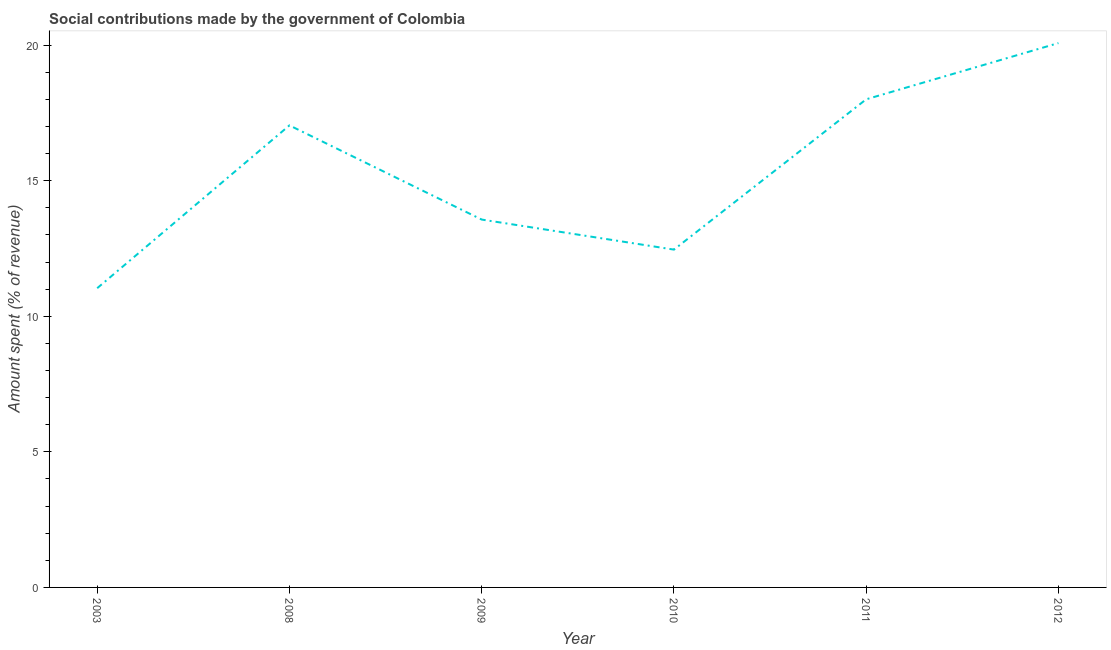What is the amount spent in making social contributions in 2009?
Offer a very short reply. 13.57. Across all years, what is the maximum amount spent in making social contributions?
Provide a succinct answer. 20.08. Across all years, what is the minimum amount spent in making social contributions?
Offer a terse response. 11.04. In which year was the amount spent in making social contributions maximum?
Your answer should be compact. 2012. What is the sum of the amount spent in making social contributions?
Ensure brevity in your answer.  92.18. What is the difference between the amount spent in making social contributions in 2008 and 2011?
Your response must be concise. -0.96. What is the average amount spent in making social contributions per year?
Offer a very short reply. 15.36. What is the median amount spent in making social contributions?
Offer a very short reply. 15.3. In how many years, is the amount spent in making social contributions greater than 12 %?
Offer a terse response. 5. What is the ratio of the amount spent in making social contributions in 2009 to that in 2011?
Provide a short and direct response. 0.75. What is the difference between the highest and the second highest amount spent in making social contributions?
Keep it short and to the point. 2.07. What is the difference between the highest and the lowest amount spent in making social contributions?
Your response must be concise. 9.04. How many years are there in the graph?
Your answer should be compact. 6. What is the difference between two consecutive major ticks on the Y-axis?
Make the answer very short. 5. Does the graph contain grids?
Offer a very short reply. No. What is the title of the graph?
Your response must be concise. Social contributions made by the government of Colombia. What is the label or title of the X-axis?
Offer a terse response. Year. What is the label or title of the Y-axis?
Ensure brevity in your answer.  Amount spent (% of revenue). What is the Amount spent (% of revenue) in 2003?
Keep it short and to the point. 11.04. What is the Amount spent (% of revenue) of 2008?
Offer a very short reply. 17.04. What is the Amount spent (% of revenue) of 2009?
Offer a very short reply. 13.57. What is the Amount spent (% of revenue) of 2010?
Ensure brevity in your answer.  12.46. What is the Amount spent (% of revenue) in 2011?
Give a very brief answer. 18. What is the Amount spent (% of revenue) of 2012?
Your answer should be compact. 20.08. What is the difference between the Amount spent (% of revenue) in 2003 and 2008?
Your response must be concise. -6. What is the difference between the Amount spent (% of revenue) in 2003 and 2009?
Offer a very short reply. -2.53. What is the difference between the Amount spent (% of revenue) in 2003 and 2010?
Ensure brevity in your answer.  -1.42. What is the difference between the Amount spent (% of revenue) in 2003 and 2011?
Your answer should be compact. -6.97. What is the difference between the Amount spent (% of revenue) in 2003 and 2012?
Your answer should be compact. -9.04. What is the difference between the Amount spent (% of revenue) in 2008 and 2009?
Offer a very short reply. 3.47. What is the difference between the Amount spent (% of revenue) in 2008 and 2010?
Make the answer very short. 4.58. What is the difference between the Amount spent (% of revenue) in 2008 and 2011?
Your answer should be compact. -0.96. What is the difference between the Amount spent (% of revenue) in 2008 and 2012?
Offer a terse response. -3.04. What is the difference between the Amount spent (% of revenue) in 2009 and 2010?
Your answer should be very brief. 1.11. What is the difference between the Amount spent (% of revenue) in 2009 and 2011?
Keep it short and to the point. -4.44. What is the difference between the Amount spent (% of revenue) in 2009 and 2012?
Provide a short and direct response. -6.51. What is the difference between the Amount spent (% of revenue) in 2010 and 2011?
Your answer should be very brief. -5.54. What is the difference between the Amount spent (% of revenue) in 2010 and 2012?
Provide a succinct answer. -7.62. What is the difference between the Amount spent (% of revenue) in 2011 and 2012?
Give a very brief answer. -2.07. What is the ratio of the Amount spent (% of revenue) in 2003 to that in 2008?
Give a very brief answer. 0.65. What is the ratio of the Amount spent (% of revenue) in 2003 to that in 2009?
Your answer should be very brief. 0.81. What is the ratio of the Amount spent (% of revenue) in 2003 to that in 2010?
Provide a short and direct response. 0.89. What is the ratio of the Amount spent (% of revenue) in 2003 to that in 2011?
Offer a very short reply. 0.61. What is the ratio of the Amount spent (% of revenue) in 2003 to that in 2012?
Ensure brevity in your answer.  0.55. What is the ratio of the Amount spent (% of revenue) in 2008 to that in 2009?
Provide a succinct answer. 1.26. What is the ratio of the Amount spent (% of revenue) in 2008 to that in 2010?
Make the answer very short. 1.37. What is the ratio of the Amount spent (% of revenue) in 2008 to that in 2011?
Provide a short and direct response. 0.95. What is the ratio of the Amount spent (% of revenue) in 2008 to that in 2012?
Offer a terse response. 0.85. What is the ratio of the Amount spent (% of revenue) in 2009 to that in 2010?
Your answer should be very brief. 1.09. What is the ratio of the Amount spent (% of revenue) in 2009 to that in 2011?
Your answer should be very brief. 0.75. What is the ratio of the Amount spent (% of revenue) in 2009 to that in 2012?
Your response must be concise. 0.68. What is the ratio of the Amount spent (% of revenue) in 2010 to that in 2011?
Offer a terse response. 0.69. What is the ratio of the Amount spent (% of revenue) in 2010 to that in 2012?
Your answer should be very brief. 0.62. What is the ratio of the Amount spent (% of revenue) in 2011 to that in 2012?
Make the answer very short. 0.9. 